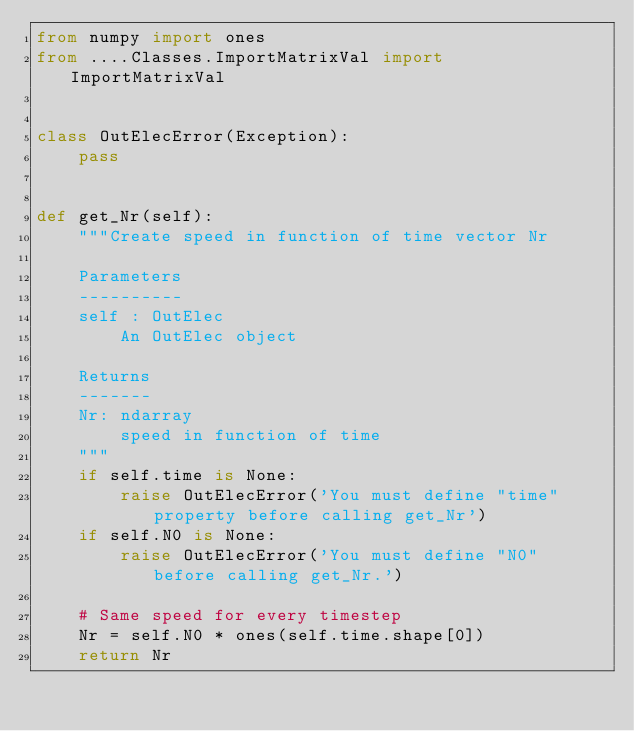<code> <loc_0><loc_0><loc_500><loc_500><_Python_>from numpy import ones
from ....Classes.ImportMatrixVal import ImportMatrixVal


class OutElecError(Exception):
    pass


def get_Nr(self):
    """Create speed in function of time vector Nr

    Parameters
    ----------
    self : OutElec
        An OutElec object

    Returns
    -------
    Nr: ndarray
        speed in function of time
    """
    if self.time is None:
        raise OutElecError('You must define "time" property before calling get_Nr')
    if self.N0 is None:
        raise OutElecError('You must define "N0" before calling get_Nr.')

    # Same speed for every timestep
    Nr = self.N0 * ones(self.time.shape[0])
    return Nr
</code> 